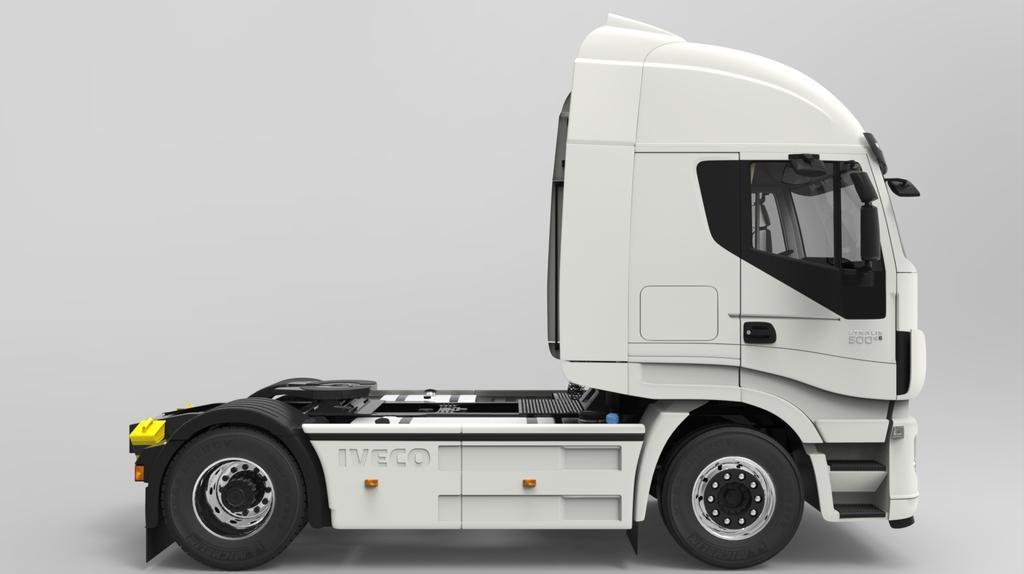How would you summarize this image in a sentence or two? We can see vehicle on the surface. In the background it is white. 